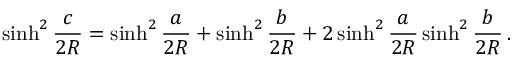Convert formula to latex. <formula><loc_0><loc_0><loc_500><loc_500>\sinh ^ { 2 } { \frac { c } { 2 R } } = \sinh ^ { 2 } { \frac { a } { 2 R } } + \sinh ^ { 2 } { \frac { b } { 2 R } } + 2 \sinh ^ { 2 } { \frac { a } { 2 R } } \sinh ^ { 2 } { \frac { b } { 2 R } } \, .</formula> 